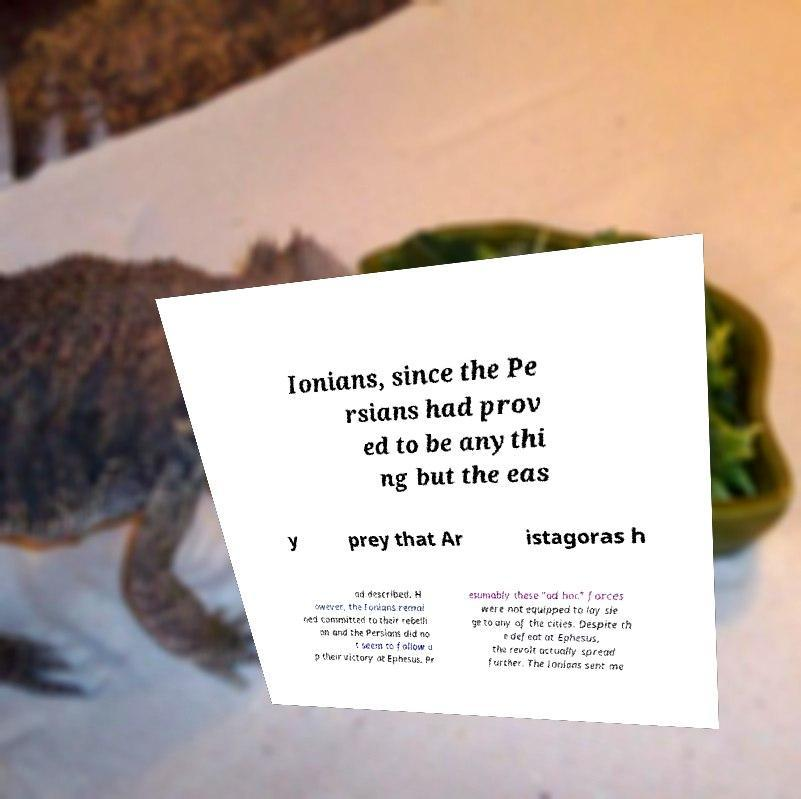Can you accurately transcribe the text from the provided image for me? Ionians, since the Pe rsians had prov ed to be anythi ng but the eas y prey that Ar istagoras h ad described. H owever, the Ionians remai ned committed to their rebelli on and the Persians did no t seem to follow u p their victory at Ephesus. Pr esumably these "ad hoc" forces were not equipped to lay sie ge to any of the cities. Despite th e defeat at Ephesus, the revolt actually spread further. The Ionians sent me 